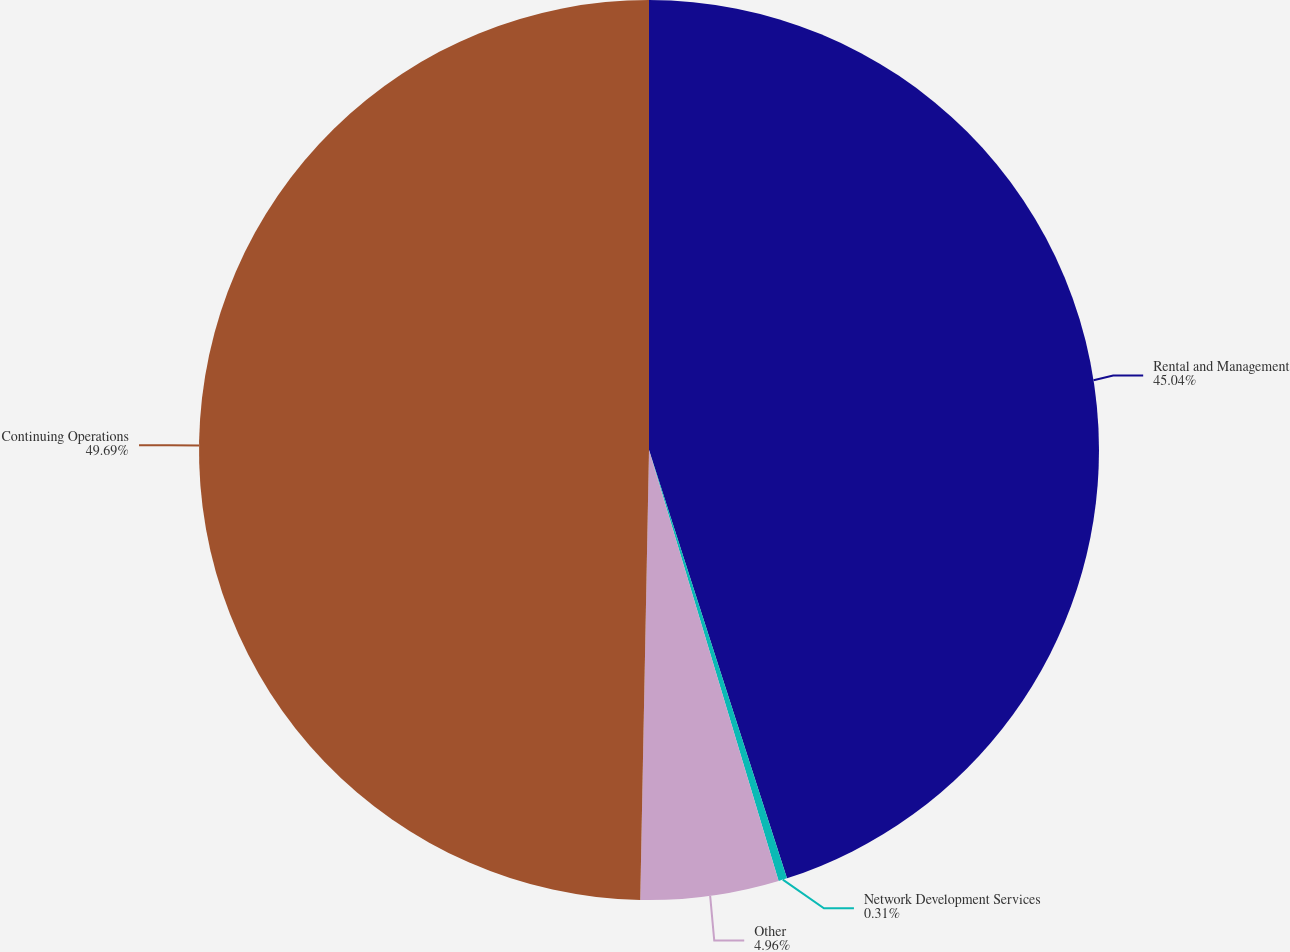Convert chart. <chart><loc_0><loc_0><loc_500><loc_500><pie_chart><fcel>Rental and Management<fcel>Network Development Services<fcel>Other<fcel>Continuing Operations<nl><fcel>45.04%<fcel>0.31%<fcel>4.96%<fcel>49.69%<nl></chart> 